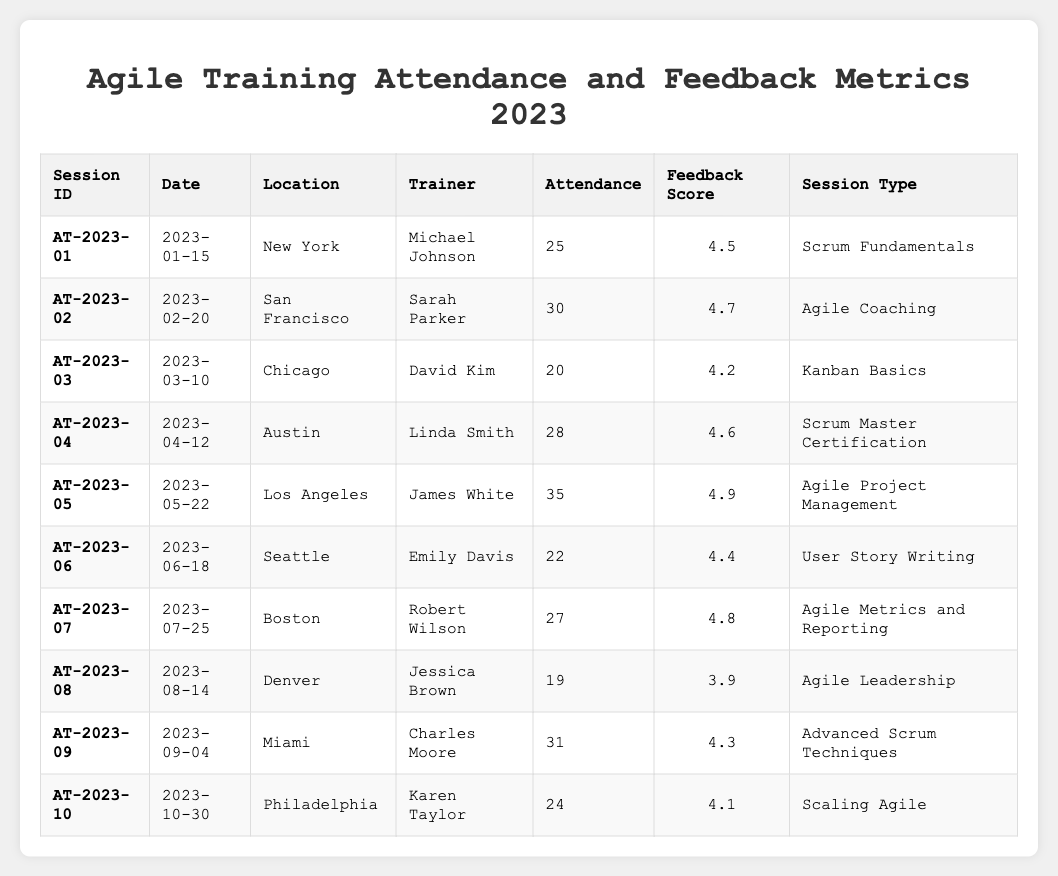What is the date of the Agile Project Management training session? The Agile Project Management training session is recorded under the Session ID AT-2023-05. When looking at the corresponding row, the date is noted as 2023-05-22.
Answer: 2023-05-22 Who conducted the Scrum Master Certification workshop? The Session ID AT-2023-04 is linked to the Scrum Master Certification session. By checking the trainer listed in that row, Linda Smith conducted the workshop.
Answer: Linda Smith What was the attendance for the User Story Writing session? In the row for the User Story Writing session, which corresponds to Session ID AT-2023-06, the attendance column shows the number as 22.
Answer: 22 Which session type had the highest Feedback Score? By reviewing the Feedback Scores, the Agile Project Management session (AT-2023-05) scored 4.9, which is the highest among all sessions listed.
Answer: Agile Project Management What is the average Feedback Score of all sessions? To find the average Feedback Score, we sum all the scores (4.5 + 4.7 + 4.2 + 4.6 + 4.9 + 4.4 + 4.8 + 3.9 + 4.3 + 4.1 = 45.4) and then divide by the number of sessions (10). Thus, 45.4 / 10 = 4.54.
Answer: 4.54 Was the attendance for the Agile Leadership session greater than 20? The Agile Leadership session (Session ID AT-2023-08) has an attendance of 19. When comparing this number to 20, it is clear that 19 is less than 20.
Answer: No Which session had the least number of attendees? Reviewing the attendance numbers, the session with the lowest figure is Agile Leadership (AT-2023-08) with an attendance of 19, lower than all other sessions.
Answer: Agile Leadership What is the difference in attendance between the most and least attended sessions? The most attended session is Agile Project Management (AT-2023-05) with an attendance of 35, and the least attended is Agile Leadership (AT-2023-08) with 19. The difference is calculated as 35 - 19 = 16.
Answer: 16 How many sessions had a Feedback Score of 4.5 or higher? Examining the Feedback Scores, the sessions with scores of 4.5 or above are: Scrum Fundamentals (4.5), Agile Coaching (4.7), Scrum Master Certification (4.6), Agile Project Management (4.9), Agile Metrics and Reporting (4.8), and Advanced Scrum Techniques (4.3), totaling 7 sessions.
Answer: 7 In what location was the Kanban Basics session held? The Kanban Basics session corresponds to Session ID AT-2023-03. Looking at that row, the location column indicates that the session was held in Chicago.
Answer: Chicago What is the total attendance for sessions held in New York and San Francisco combined? The attendance for the New York session (AT-2023-01) is 25 and for San Francisco (AT-2023-02) is 30. Adding these together gives 25 + 30 = 55.
Answer: 55 